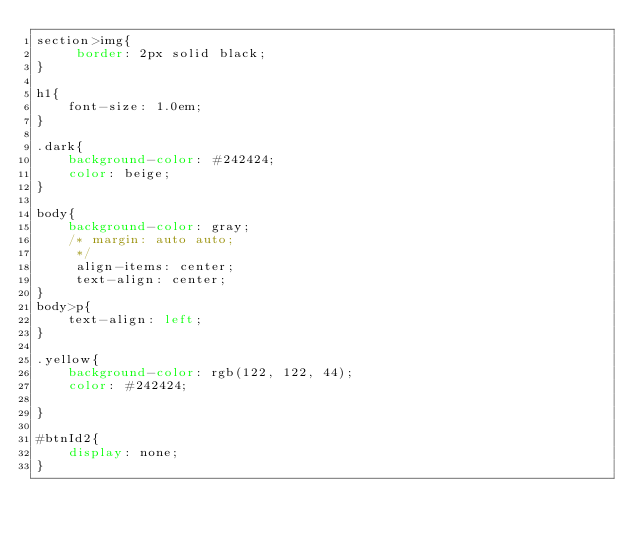Convert code to text. <code><loc_0><loc_0><loc_500><loc_500><_CSS_>section>img{
     border: 2px solid black;
}

h1{
    font-size: 1.0em;
}

.dark{
    background-color: #242424;
    color: beige;
}

body{
    background-color: gray;
    /* margin: auto auto;
     */
     align-items: center;
     text-align: center;
}
body>p{
    text-align: left;
}

.yellow{
    background-color: rgb(122, 122, 44);
    color: #242424;
    
}

#btnId2{
    display: none;
}</code> 